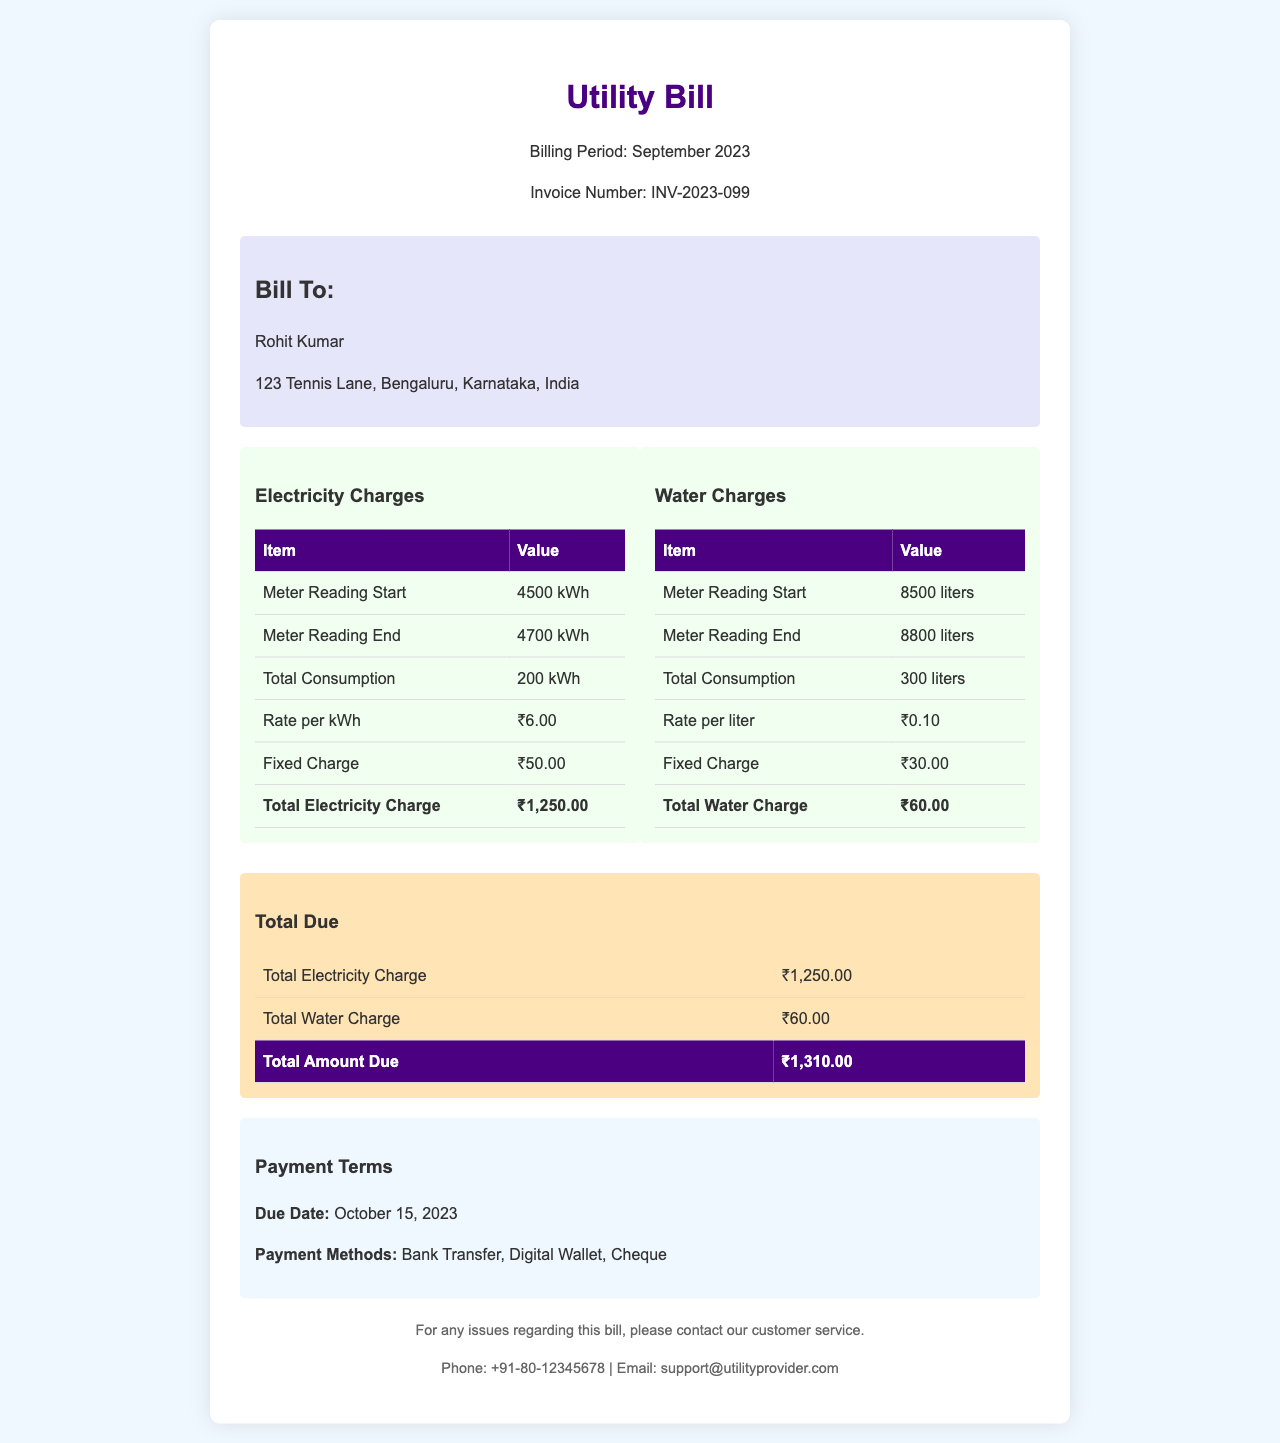What is the billing period? The billing period specified in the invoice is mentioned clearly at the top.
Answer: September 2023 Who is the bill addressed to? The recipient's name appears in the "Bill To" section of the invoice.
Answer: Rohit Kumar What is the total electricity charge? The total electricity charge is calculated in the electricity breakdown section of the invoice.
Answer: ₹1,250.00 What is the rate per liter of water? The rate per liter for water is stated in the water charges breakdown.
Answer: ₹0.10 What is the total amount due? The total amount due is the sum of total electricity and water charges, found in the totals section.
Answer: ₹1,310.00 When is the due date for payment? The due date is specified in the payment terms area of the document.
Answer: October 15, 2023 What is the meter reading start for electricity? The starting meter reading for electricity is given in the electricity charges table.
Answer: 4500 kWh How many liters of water were consumed? The total consumption of water is presented in the water charges breakdown table.
Answer: 300 liters What payment methods are accepted? The invoice lists accepted payment methods in the payment terms section.
Answer: Bank Transfer, Digital Wallet, Cheque 